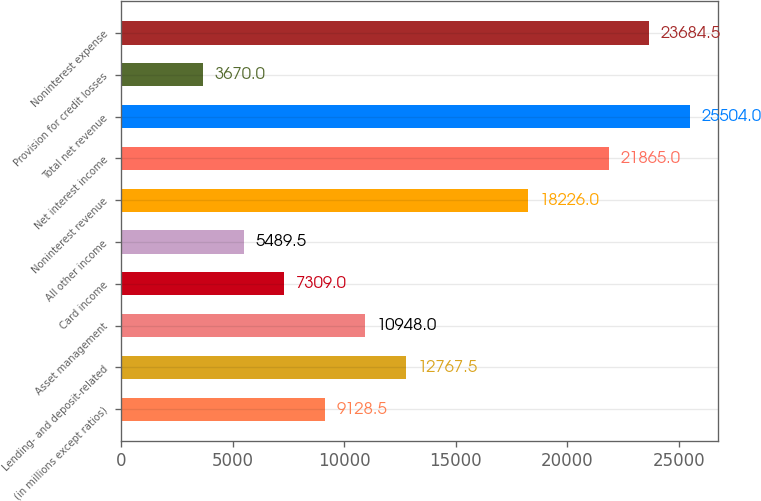Convert chart to OTSL. <chart><loc_0><loc_0><loc_500><loc_500><bar_chart><fcel>(in millions except ratios)<fcel>Lending- and deposit-related<fcel>Asset management<fcel>Card income<fcel>All other income<fcel>Noninterest revenue<fcel>Net interest income<fcel>Total net revenue<fcel>Provision for credit losses<fcel>Noninterest expense<nl><fcel>9128.5<fcel>12767.5<fcel>10948<fcel>7309<fcel>5489.5<fcel>18226<fcel>21865<fcel>25504<fcel>3670<fcel>23684.5<nl></chart> 